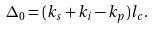<formula> <loc_0><loc_0><loc_500><loc_500>\Delta _ { 0 } = ( k _ { s } + k _ { i } - k _ { p } ) l _ { c } .</formula> 